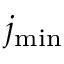Convert formula to latex. <formula><loc_0><loc_0><loc_500><loc_500>j _ { \min }</formula> 